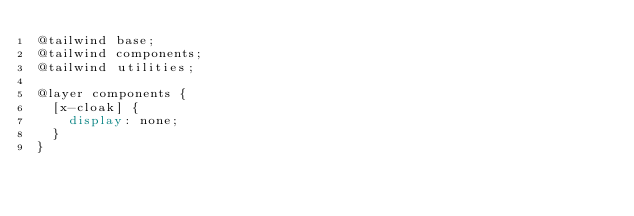Convert code to text. <code><loc_0><loc_0><loc_500><loc_500><_CSS_>@tailwind base;
@tailwind components;
@tailwind utilities;

@layer components {
  [x-cloak] {
    display: none;
  }
}
</code> 